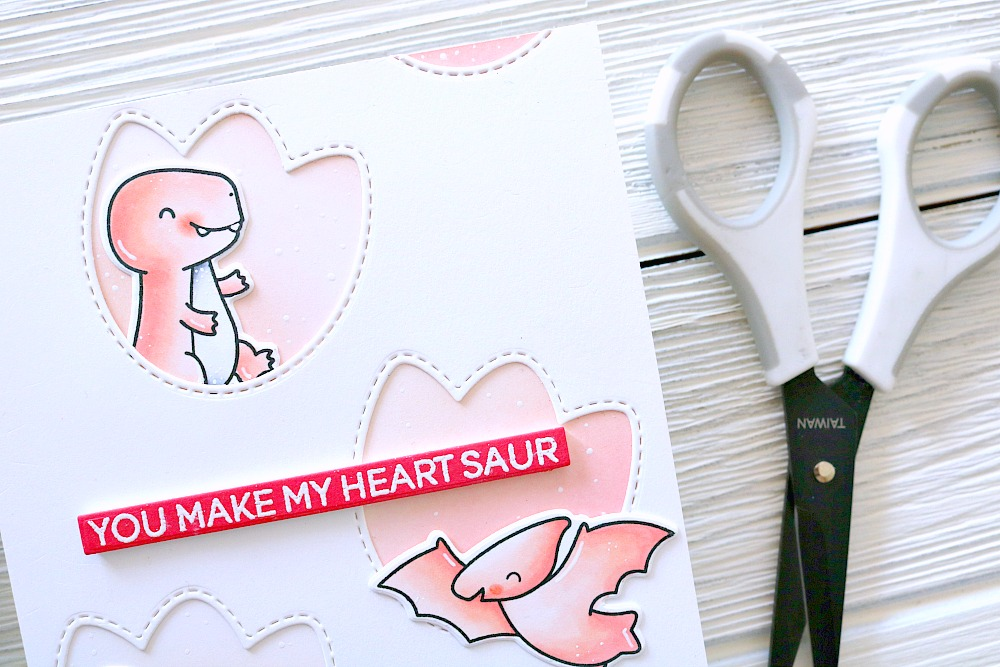What artistic techniques may have been used to create the textured background of the card, and how do these techniques contribute to the overall aesthetic of the craft? The textured background of the card appears to be achieved through a technique that could include dry embossing, where a stencil is used to create a raised pattern on paper, or through a method of applying a thin layer of paint with a sponge or brush to create a subtle texture. These techniques contribute to the overall aesthetic by adding depth and interest to the craft, making it more visually appealing than if it were just a plain white background. The dotted lines that mimic stitching further accentuate the handcrafted nature of the card, giving it a cozy, homemade feel that complements the playful and endearing theme. 